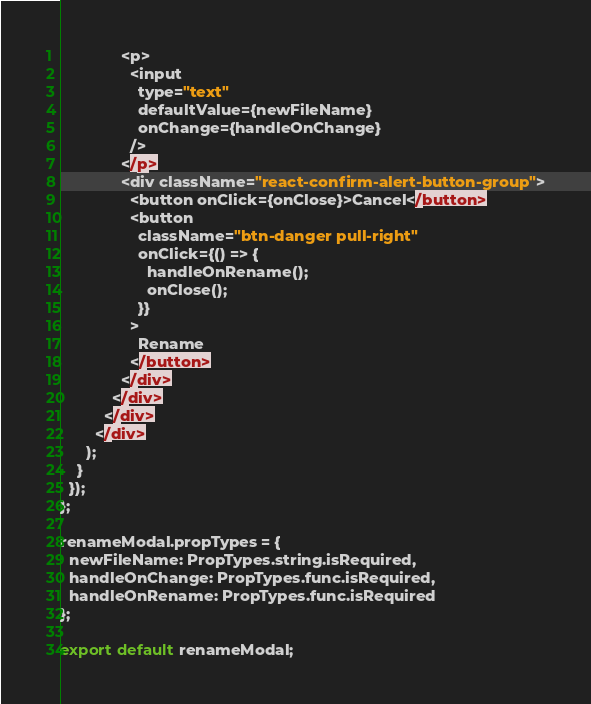<code> <loc_0><loc_0><loc_500><loc_500><_JavaScript_>              <p>
                <input
                  type="text"
                  defaultValue={newFileName}
                  onChange={handleOnChange}
                />
              </p>
              <div className="react-confirm-alert-button-group">
                <button onClick={onClose}>Cancel</button>
                <button
                  className="btn-danger pull-right"
                  onClick={() => {
                    handleOnRename();
                    onClose();
                  }}
                >
                  Rename
                </button>
              </div>
            </div>
          </div>
        </div>
      );
    }
  });
};

renameModal.propTypes = {
  newFileName: PropTypes.string.isRequired,
  handleOnChange: PropTypes.func.isRequired,
  handleOnRename: PropTypes.func.isRequired
};

export default renameModal;
</code> 